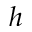Convert formula to latex. <formula><loc_0><loc_0><loc_500><loc_500>h</formula> 